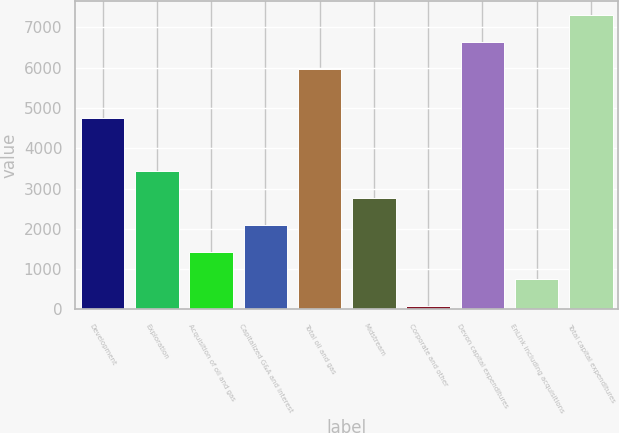Convert chart to OTSL. <chart><loc_0><loc_0><loc_500><loc_500><bar_chart><fcel>Development<fcel>Exploration<fcel>Acquisition of oil and gas<fcel>Capitalized G&A and interest<fcel>Total oil and gas<fcel>Midstream<fcel>Corporate and other<fcel>Devon capital expenditures<fcel>EnLink including acquisitions<fcel>Total capital expenditures<nl><fcel>4754<fcel>3425.5<fcel>1426<fcel>2092.5<fcel>5966<fcel>2759<fcel>93<fcel>6632.5<fcel>759.5<fcel>7299<nl></chart> 